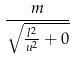Convert formula to latex. <formula><loc_0><loc_0><loc_500><loc_500>\frac { m } { \sqrt { \frac { l ^ { 2 } } { u ^ { 2 } } + 0 } }</formula> 